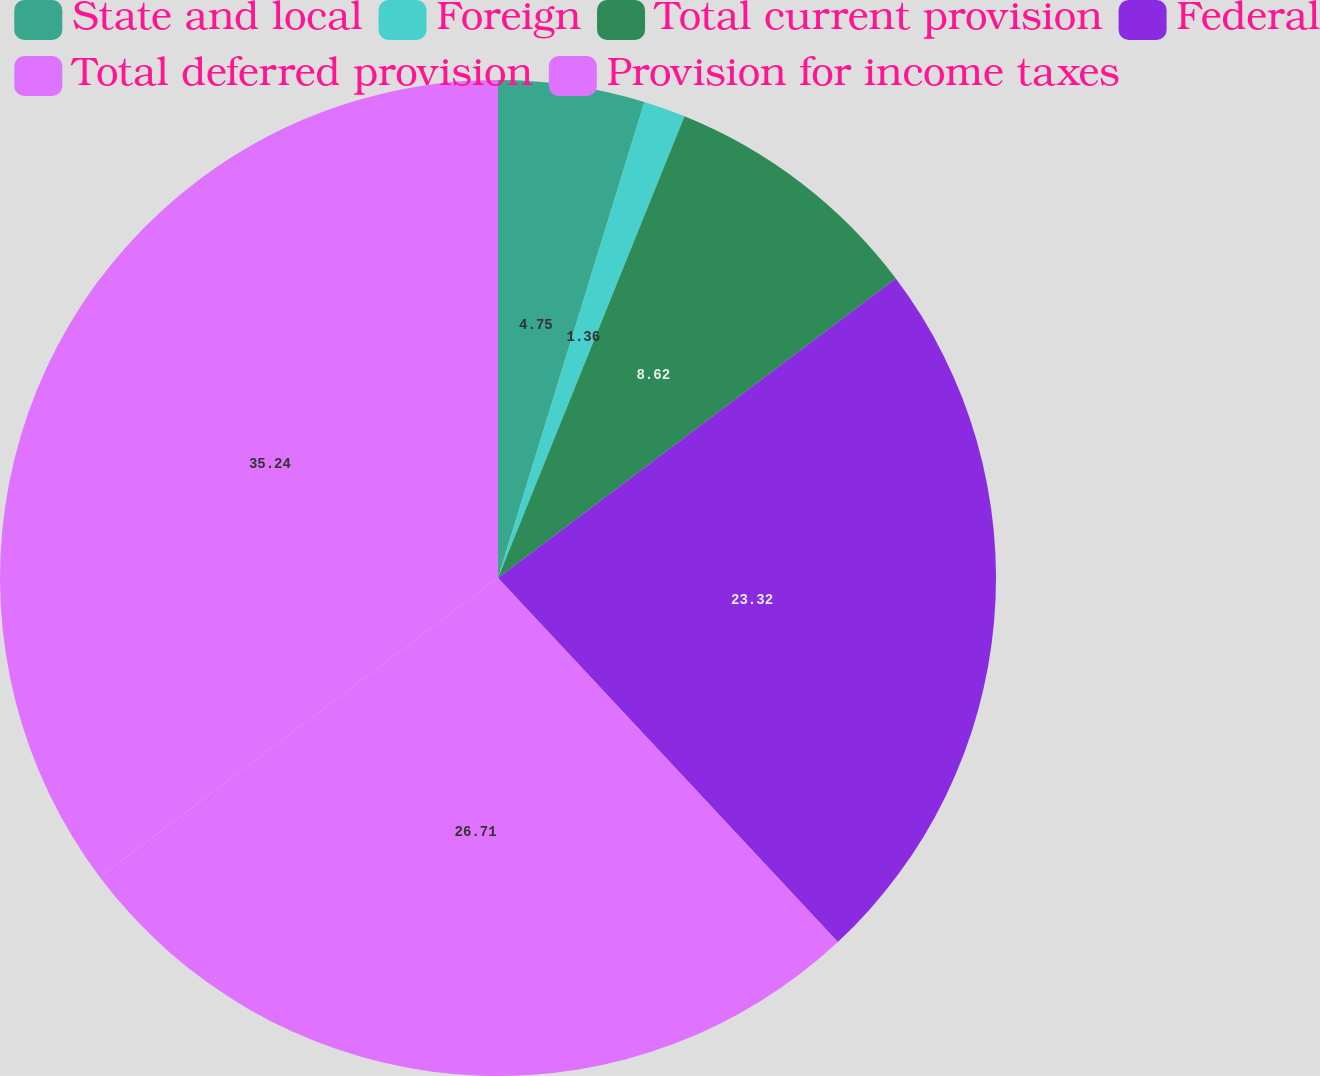<chart> <loc_0><loc_0><loc_500><loc_500><pie_chart><fcel>State and local<fcel>Foreign<fcel>Total current provision<fcel>Federal<fcel>Total deferred provision<fcel>Provision for income taxes<nl><fcel>4.75%<fcel>1.36%<fcel>8.62%<fcel>23.32%<fcel>26.71%<fcel>35.25%<nl></chart> 